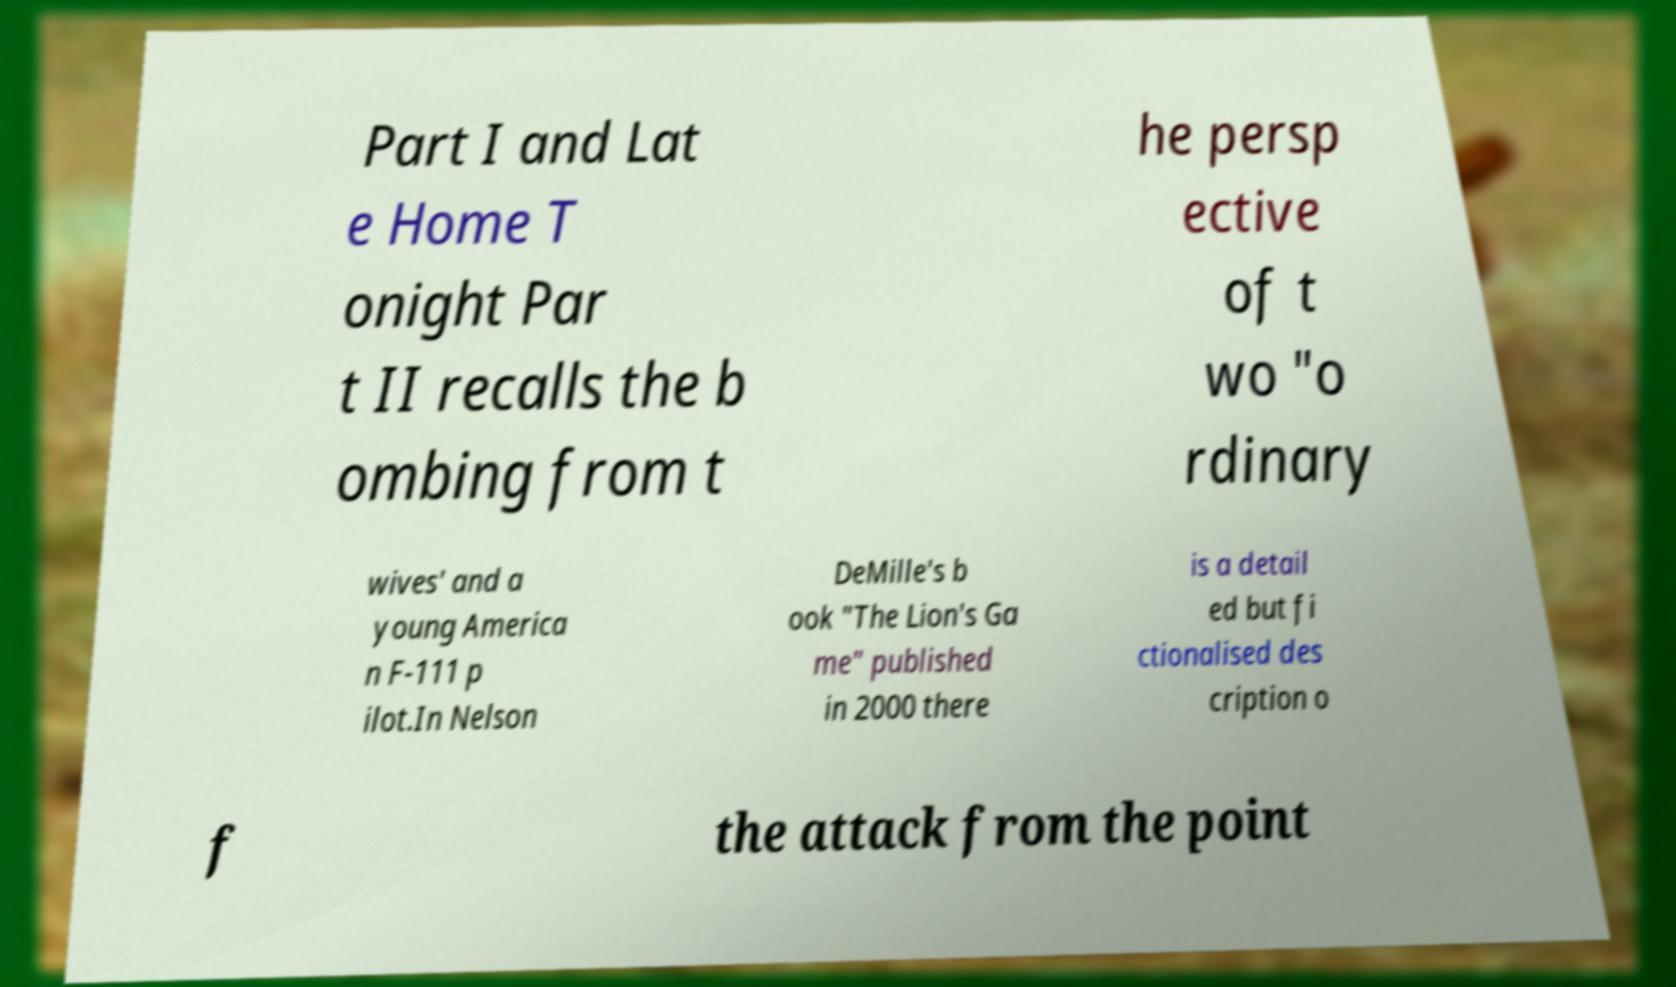There's text embedded in this image that I need extracted. Can you transcribe it verbatim? Part I and Lat e Home T onight Par t II recalls the b ombing from t he persp ective of t wo "o rdinary wives' and a young America n F-111 p ilot.In Nelson DeMille's b ook "The Lion's Ga me" published in 2000 there is a detail ed but fi ctionalised des cription o f the attack from the point 